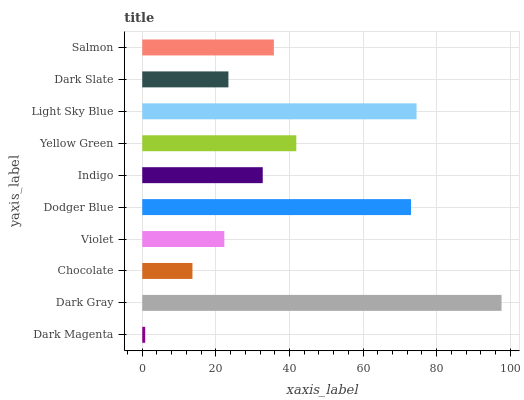Is Dark Magenta the minimum?
Answer yes or no. Yes. Is Dark Gray the maximum?
Answer yes or no. Yes. Is Chocolate the minimum?
Answer yes or no. No. Is Chocolate the maximum?
Answer yes or no. No. Is Dark Gray greater than Chocolate?
Answer yes or no. Yes. Is Chocolate less than Dark Gray?
Answer yes or no. Yes. Is Chocolate greater than Dark Gray?
Answer yes or no. No. Is Dark Gray less than Chocolate?
Answer yes or no. No. Is Salmon the high median?
Answer yes or no. Yes. Is Indigo the low median?
Answer yes or no. Yes. Is Dark Magenta the high median?
Answer yes or no. No. Is Dodger Blue the low median?
Answer yes or no. No. 